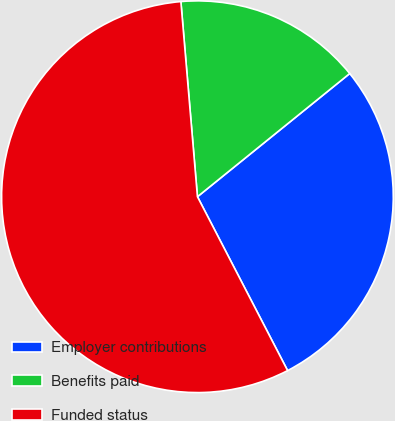Convert chart. <chart><loc_0><loc_0><loc_500><loc_500><pie_chart><fcel>Employer contributions<fcel>Benefits paid<fcel>Funded status<nl><fcel>28.21%<fcel>15.52%<fcel>56.26%<nl></chart> 